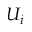Convert formula to latex. <formula><loc_0><loc_0><loc_500><loc_500>U _ { i }</formula> 